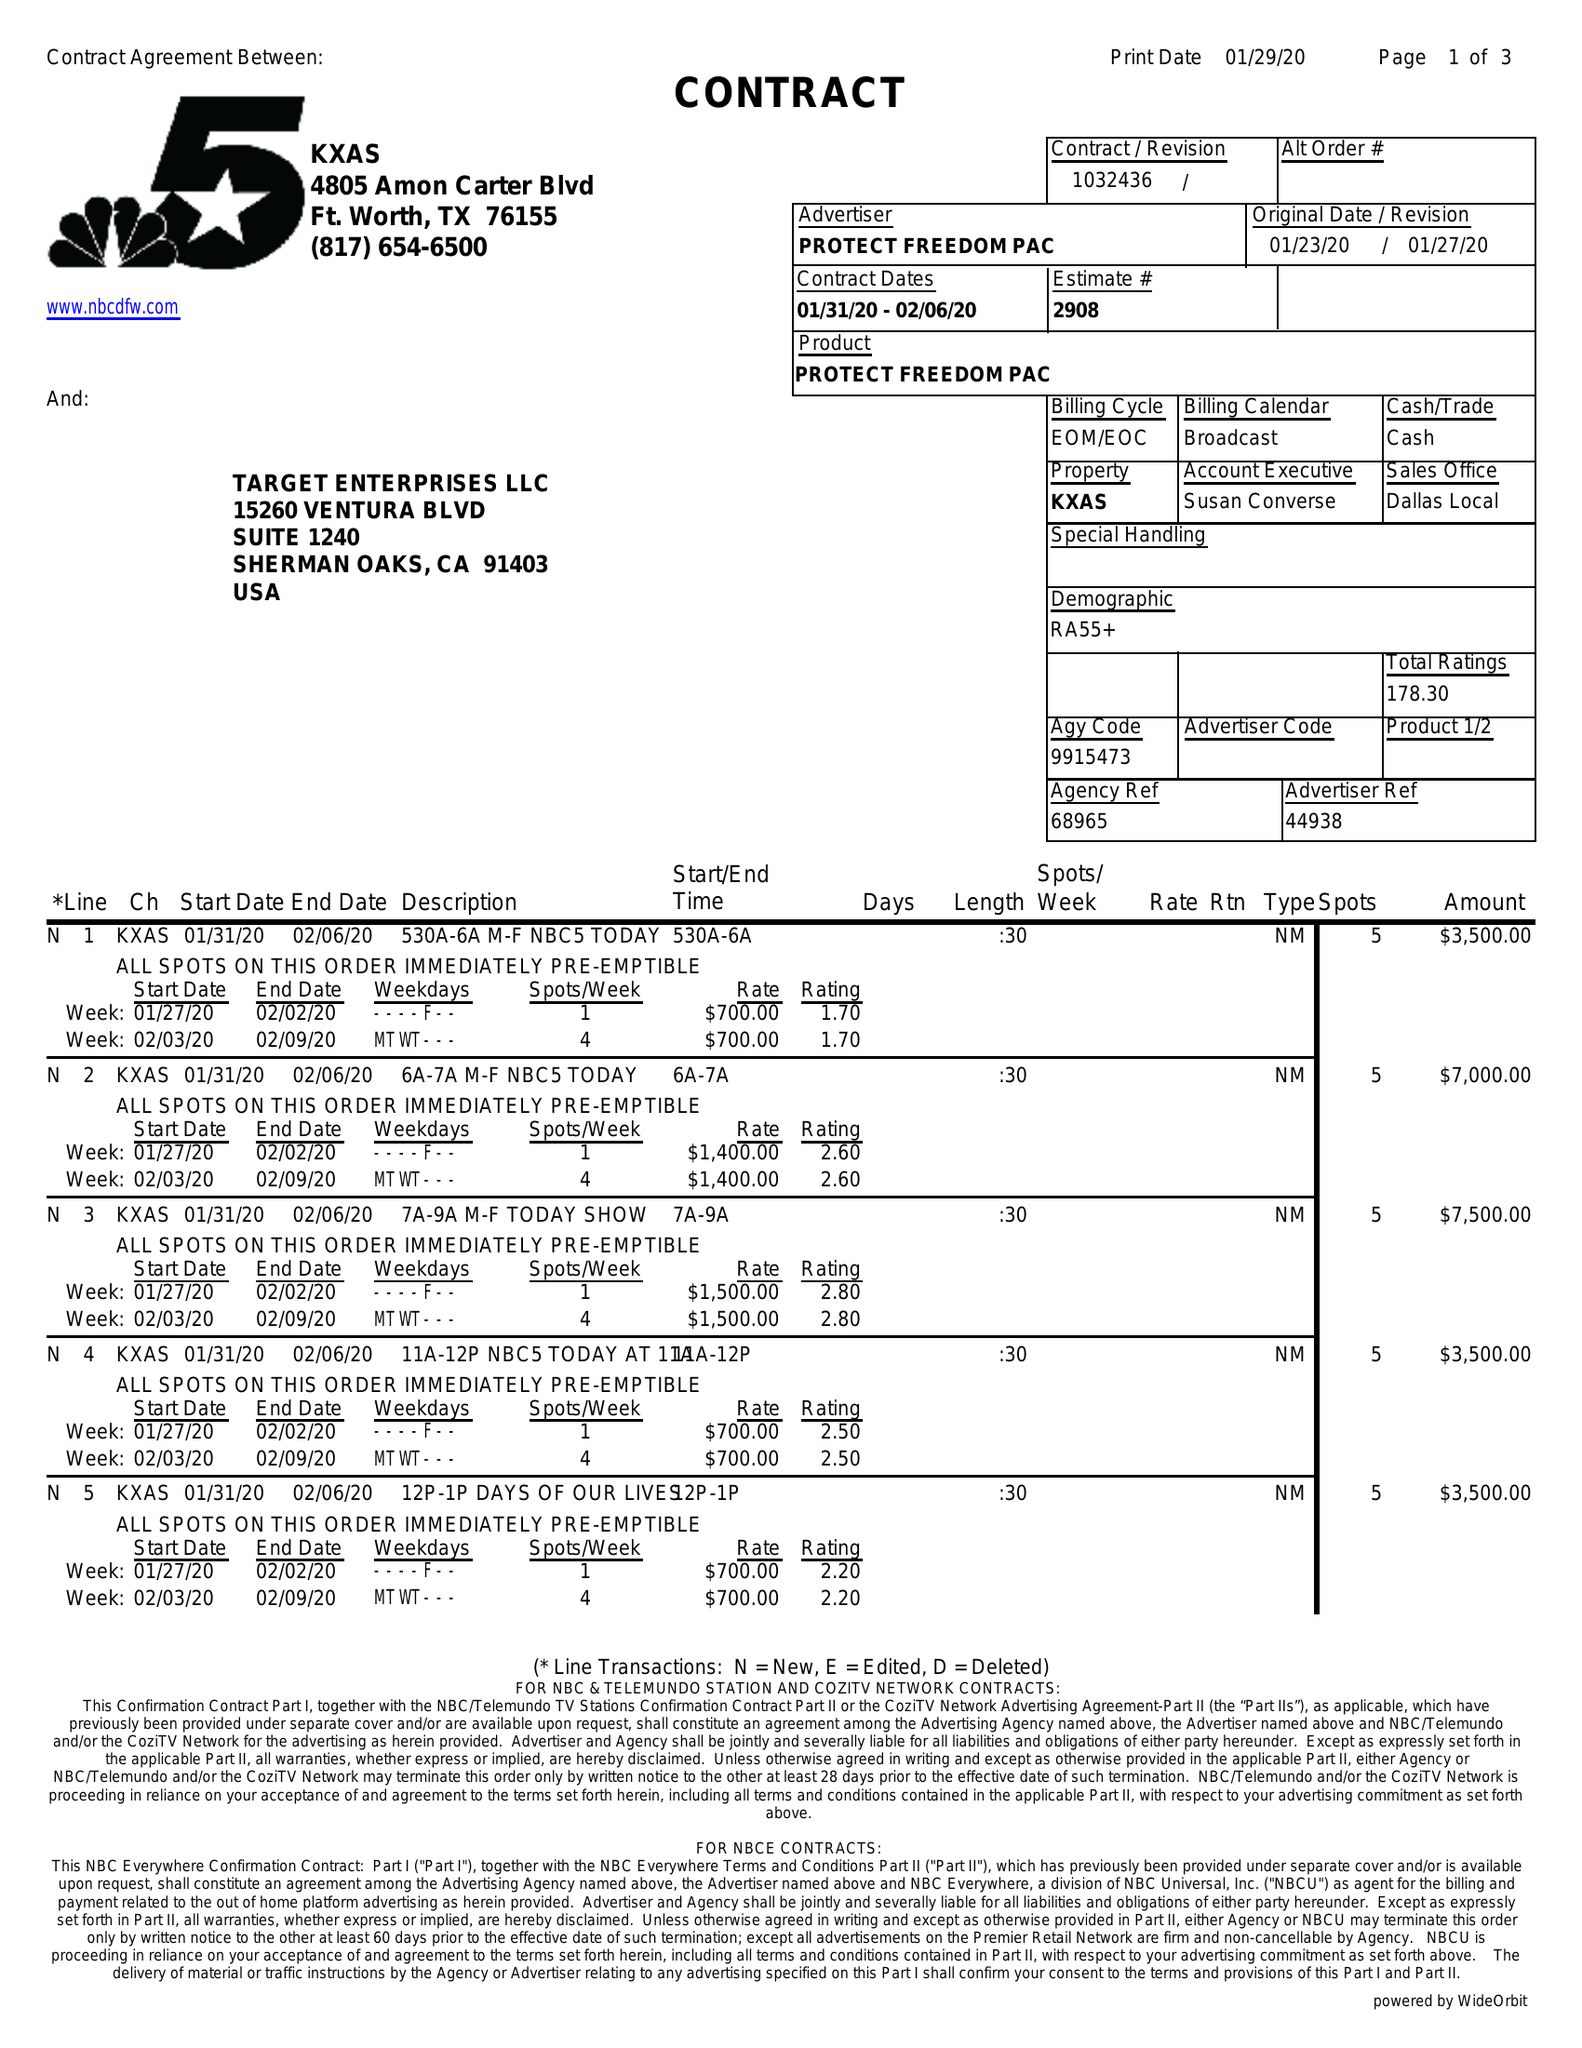What is the value for the flight_from?
Answer the question using a single word or phrase. 01/31/20 